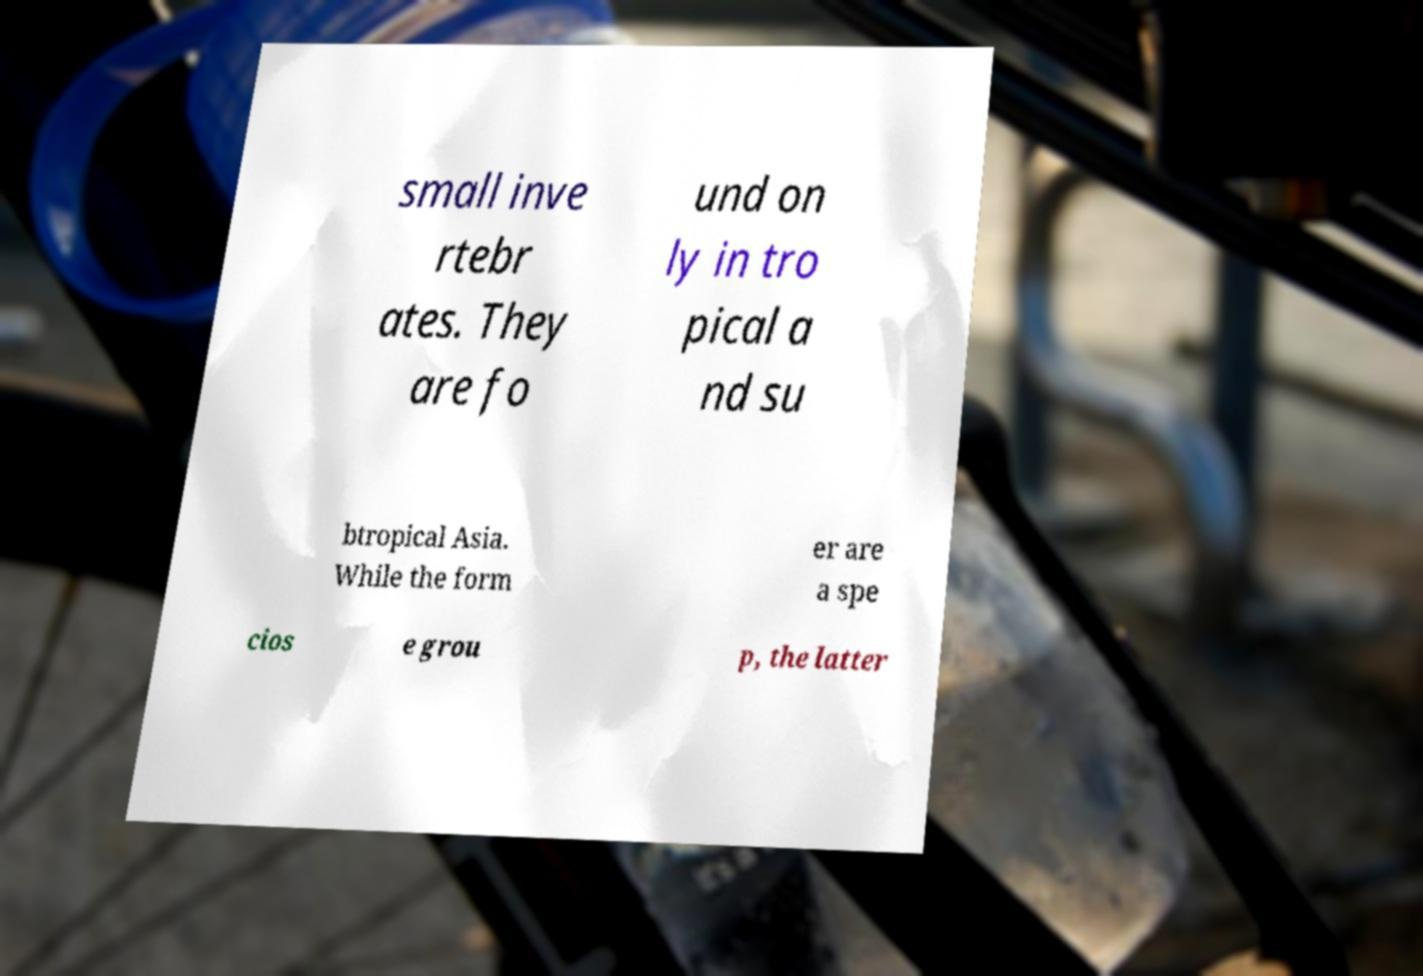Can you accurately transcribe the text from the provided image for me? small inve rtebr ates. They are fo und on ly in tro pical a nd su btropical Asia. While the form er are a spe cios e grou p, the latter 